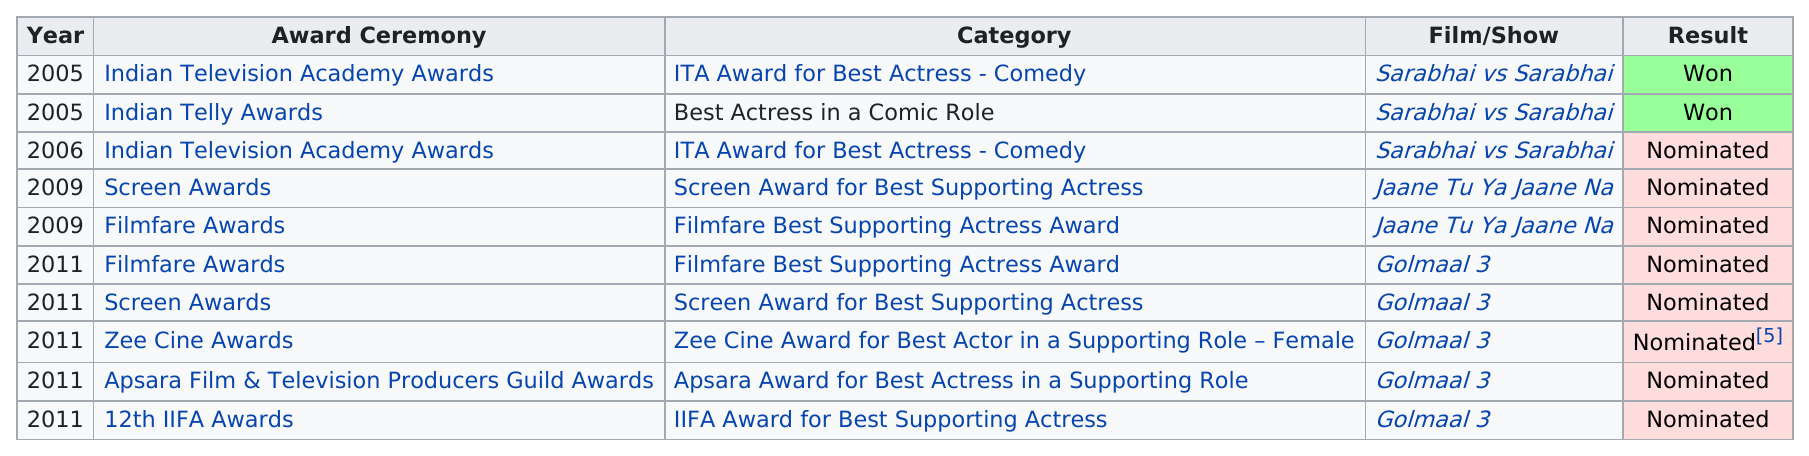Identify some key points in this picture. Jaane Tu Ya Jaane Na" was a film/show that only had two award ceremonies. In 2005, Pathak won a total of two awards. In 2011, Pathak received the most awards and/or nominations. The 2011 Filmfare Awards and the 2011 Screen Awards were both held for the movie "Golmaal 3". Jaane Tu Ya Jaane Na... is the film/show that is listed the least on this chart. 